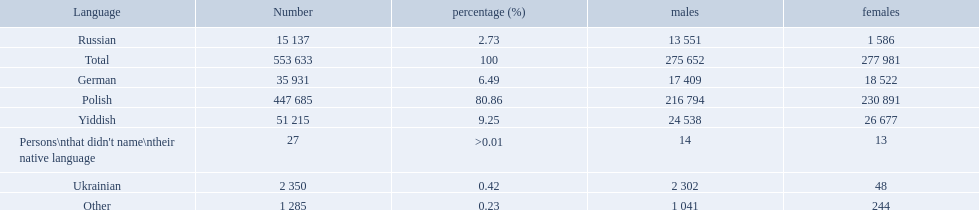How many speakers are represented in polish? 447 685. How many represented speakers are yiddish? 51 215. What is the total number of speakers? 553 633. What language makes a majority Polish. What the the total number of speakers? 553 633. 